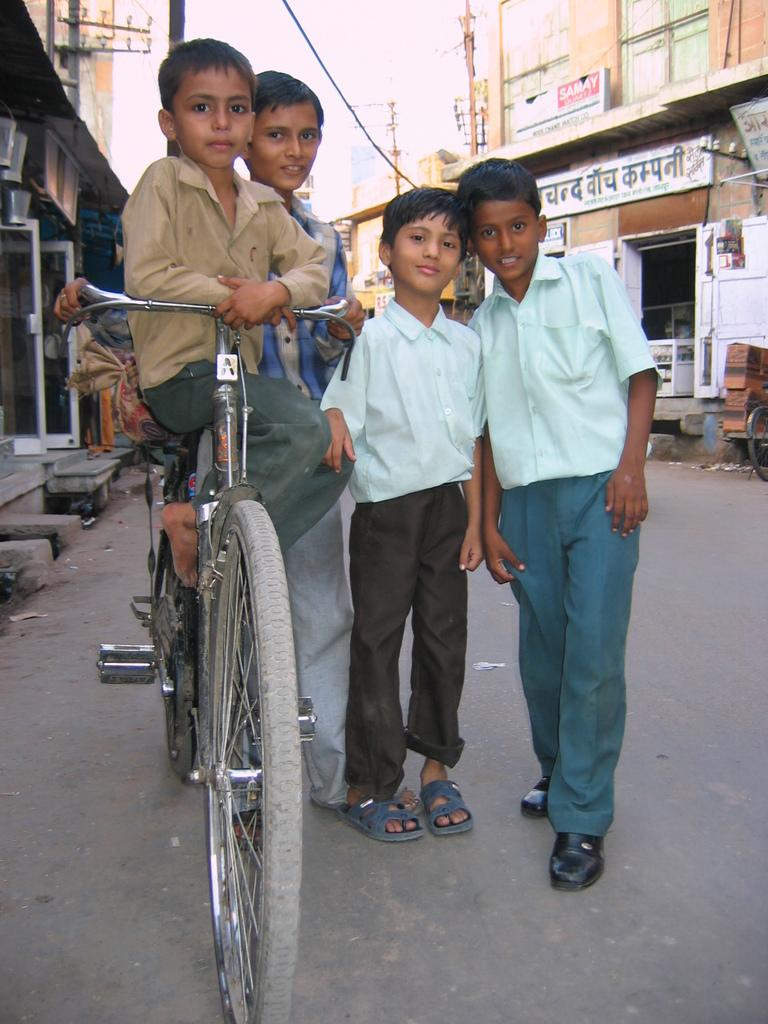How many boys are present in the image? There are 3 boys standing in the image. What is one of the boys doing in the image? One boy is sitting on a bicycle. Where are the boys located in the image? The boys are on a road. What can be seen in the background of the image? There are buildings, poles, and the sky visible in the background. What type of spy equipment can be seen in the hands of the boys in the image? There is no spy equipment visible in the hands of the boys in the image. Can you see a rabbit hopping in the background of the image? There is no rabbit present in the image; only buildings, poles, and the sky are visible in the background. 